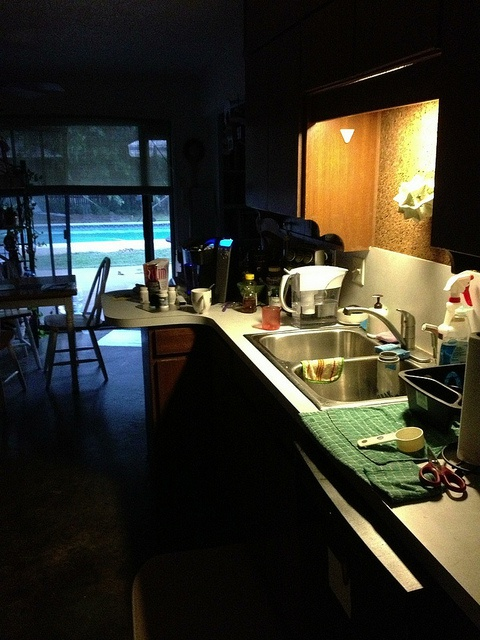Describe the objects in this image and their specific colors. I can see sink in black, olive, and tan tones, chair in black, navy, darkblue, and gray tones, dining table in black, navy, darkblue, and gray tones, chair in black, gray, and darkblue tones, and scissors in black, maroon, and gray tones in this image. 